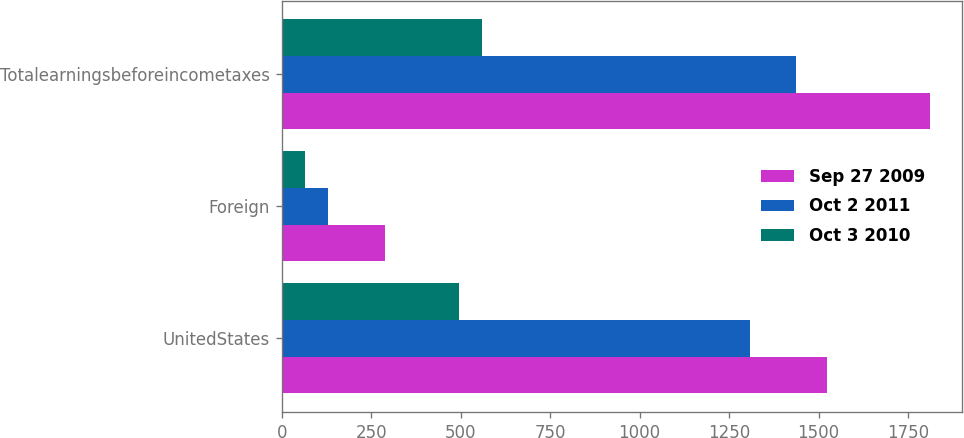Convert chart. <chart><loc_0><loc_0><loc_500><loc_500><stacked_bar_chart><ecel><fcel>UnitedStates<fcel>Foreign<fcel>Totalearningsbeforeincometaxes<nl><fcel>Sep 27 2009<fcel>1523.4<fcel>287.7<fcel>1811.1<nl><fcel>Oct 2 2011<fcel>1308.9<fcel>128.1<fcel>1437<nl><fcel>Oct 3 2010<fcel>494.6<fcel>65.3<fcel>559.9<nl></chart> 